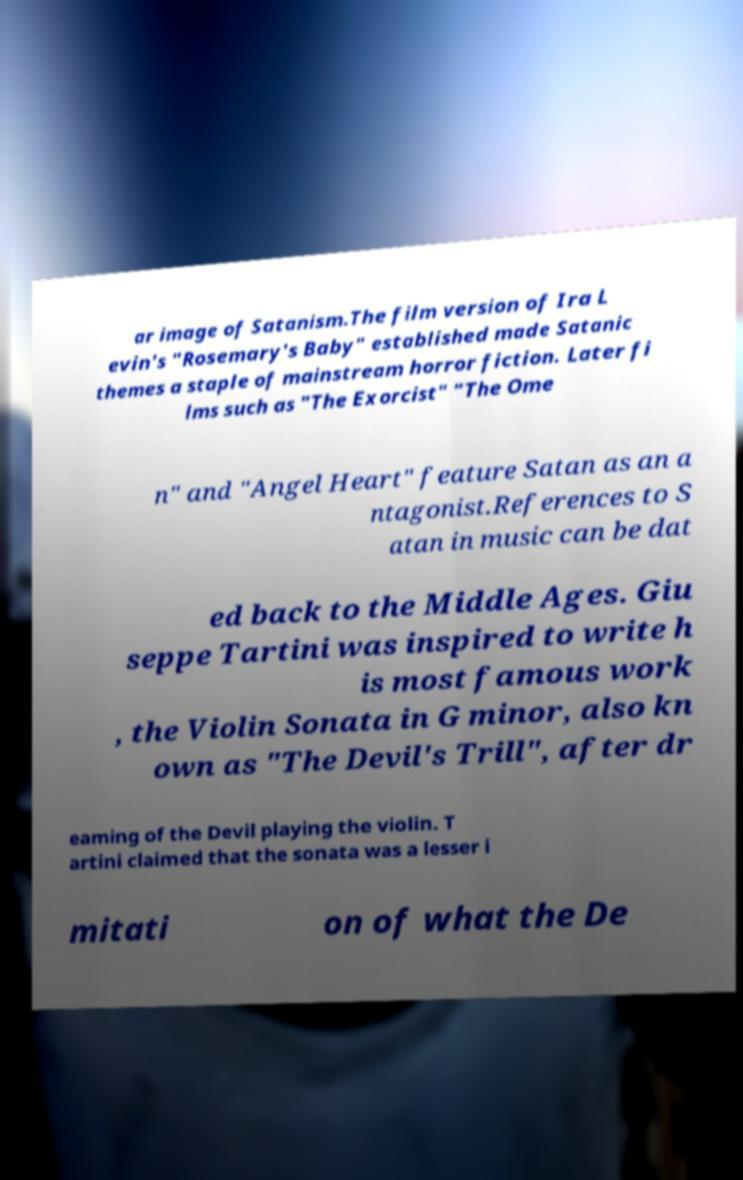Could you extract and type out the text from this image? ar image of Satanism.The film version of Ira L evin's "Rosemary's Baby" established made Satanic themes a staple of mainstream horror fiction. Later fi lms such as "The Exorcist" "The Ome n" and "Angel Heart" feature Satan as an a ntagonist.References to S atan in music can be dat ed back to the Middle Ages. Giu seppe Tartini was inspired to write h is most famous work , the Violin Sonata in G minor, also kn own as "The Devil's Trill", after dr eaming of the Devil playing the violin. T artini claimed that the sonata was a lesser i mitati on of what the De 